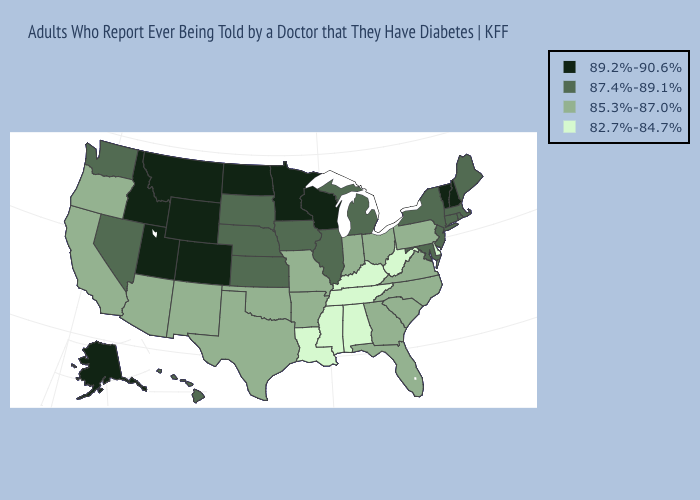Among the states that border Ohio , which have the lowest value?
Write a very short answer. Kentucky, West Virginia. What is the value of New Jersey?
Answer briefly. 87.4%-89.1%. Name the states that have a value in the range 85.3%-87.0%?
Keep it brief. Arizona, Arkansas, California, Florida, Georgia, Indiana, Missouri, New Mexico, North Carolina, Ohio, Oklahoma, Oregon, Pennsylvania, South Carolina, Texas, Virginia. Does Utah have the same value as Wyoming?
Short answer required. Yes. Which states hav the highest value in the MidWest?
Be succinct. Minnesota, North Dakota, Wisconsin. Among the states that border Montana , which have the highest value?
Write a very short answer. Idaho, North Dakota, Wyoming. What is the highest value in the USA?
Give a very brief answer. 89.2%-90.6%. Does California have a lower value than Washington?
Be succinct. Yes. What is the value of Ohio?
Concise answer only. 85.3%-87.0%. What is the highest value in the USA?
Give a very brief answer. 89.2%-90.6%. Among the states that border Iowa , does Missouri have the lowest value?
Give a very brief answer. Yes. What is the highest value in the West ?
Quick response, please. 89.2%-90.6%. Name the states that have a value in the range 85.3%-87.0%?
Be succinct. Arizona, Arkansas, California, Florida, Georgia, Indiana, Missouri, New Mexico, North Carolina, Ohio, Oklahoma, Oregon, Pennsylvania, South Carolina, Texas, Virginia. What is the value of Arkansas?
Concise answer only. 85.3%-87.0%. Does Maryland have the highest value in the South?
Be succinct. Yes. 